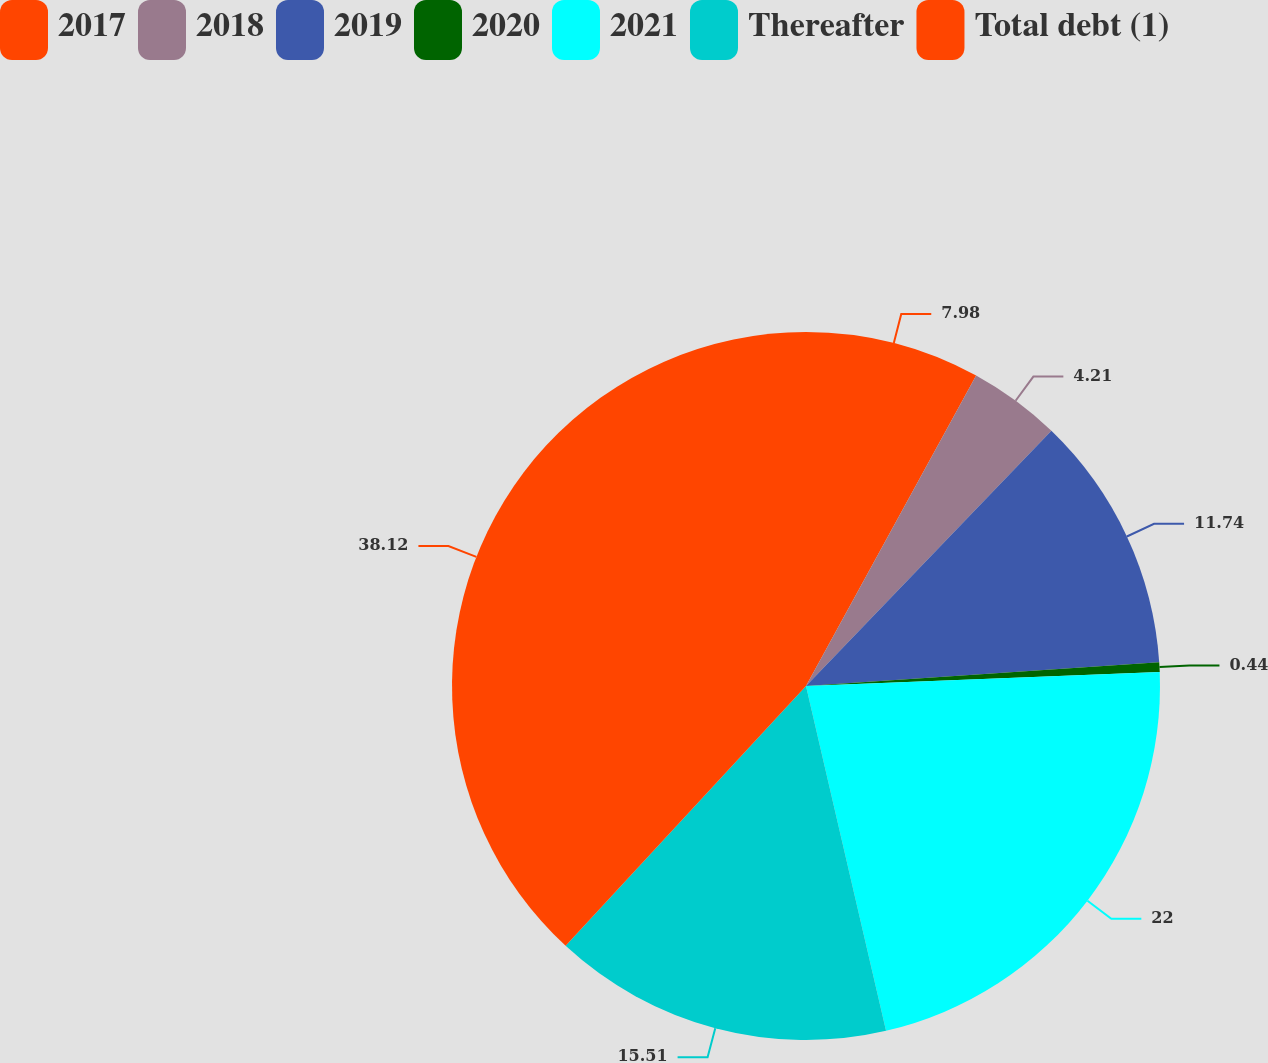Convert chart to OTSL. <chart><loc_0><loc_0><loc_500><loc_500><pie_chart><fcel>2017<fcel>2018<fcel>2019<fcel>2020<fcel>2021<fcel>Thereafter<fcel>Total debt (1)<nl><fcel>7.98%<fcel>4.21%<fcel>11.74%<fcel>0.44%<fcel>22.0%<fcel>15.51%<fcel>38.12%<nl></chart> 